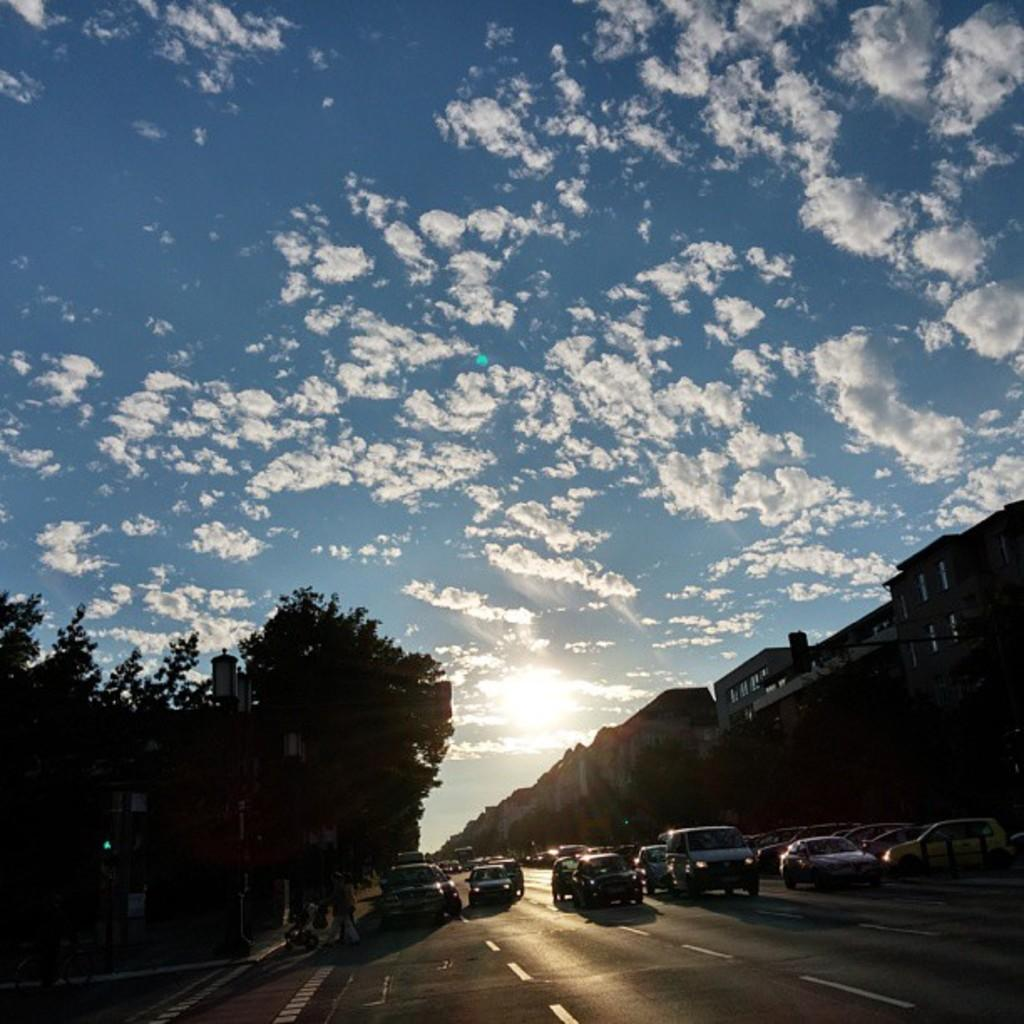What can be seen on the road in the image? There are vehicles on the road in the image. What structures are present in the image? There are buildings in the image. What type of vegetation is visible in the image? There are trees in the image. What type of illumination is present in the image? There are lights in the image. What type of vertical structures are present in the image? There are poles in the image. What can be seen in the background of the image? The sky with clouds is visible in the background of the image. Where is the bedroom located in the image? There is no bedroom present in the image. Can you see an island in the image? There is no island present in the image. What type of jewel is featured in the image? There is no jewel present in the image. 